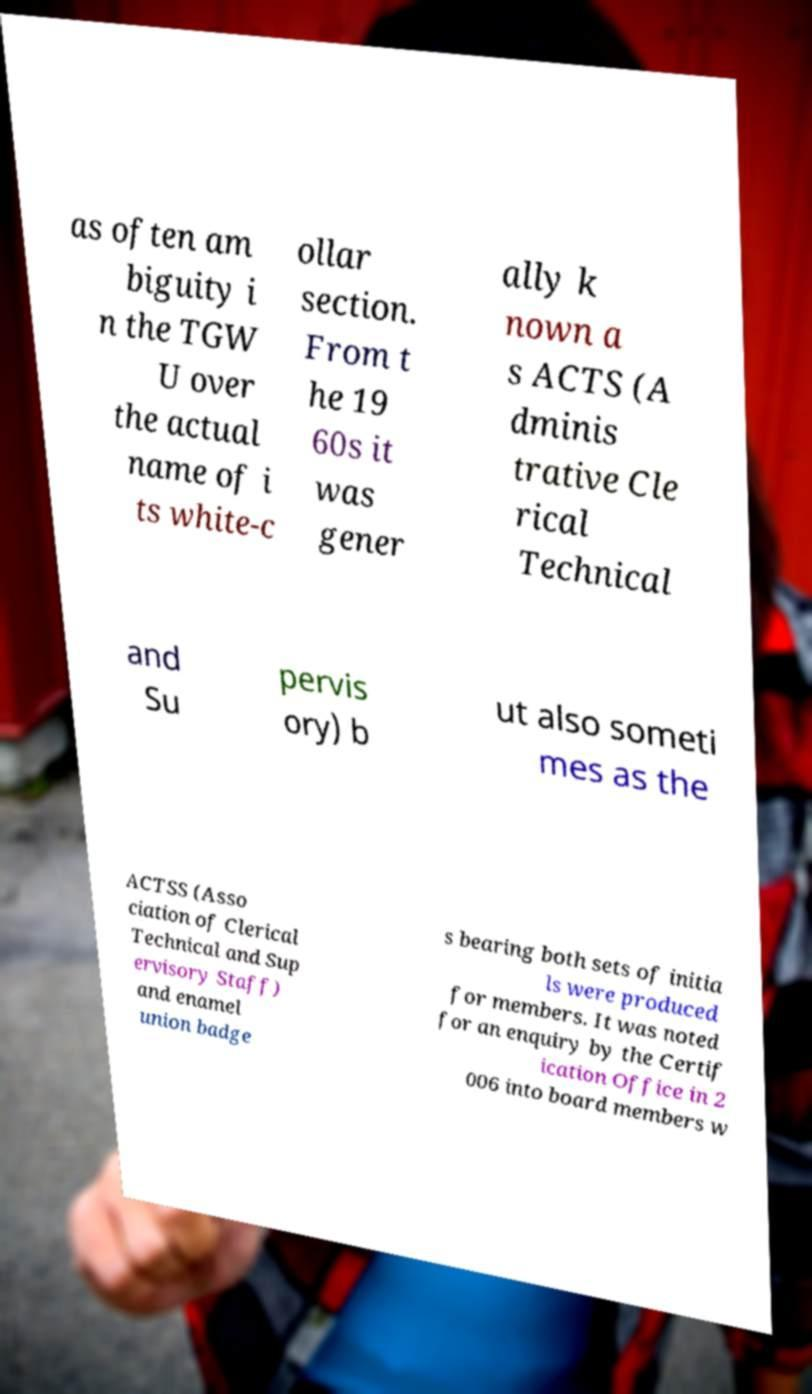Could you assist in decoding the text presented in this image and type it out clearly? as often am biguity i n the TGW U over the actual name of i ts white-c ollar section. From t he 19 60s it was gener ally k nown a s ACTS (A dminis trative Cle rical Technical and Su pervis ory) b ut also someti mes as the ACTSS (Asso ciation of Clerical Technical and Sup ervisory Staff) and enamel union badge s bearing both sets of initia ls were produced for members. It was noted for an enquiry by the Certif ication Office in 2 006 into board members w 